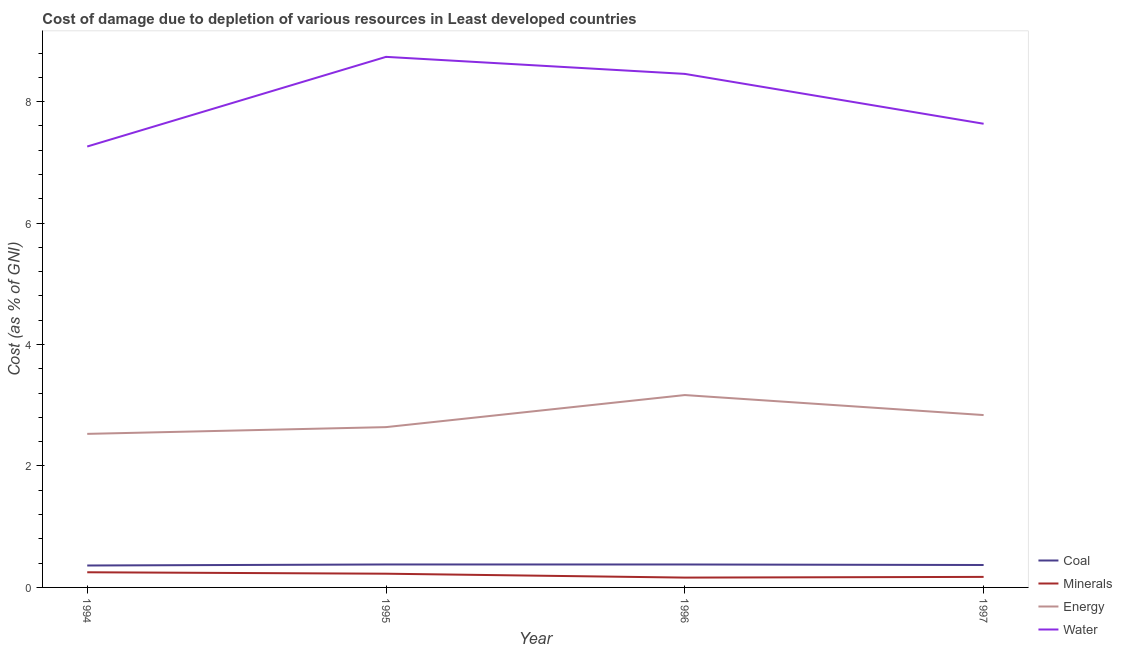Is the number of lines equal to the number of legend labels?
Your answer should be compact. Yes. What is the cost of damage due to depletion of minerals in 1994?
Make the answer very short. 0.25. Across all years, what is the maximum cost of damage due to depletion of minerals?
Give a very brief answer. 0.25. Across all years, what is the minimum cost of damage due to depletion of energy?
Your answer should be very brief. 2.53. What is the total cost of damage due to depletion of energy in the graph?
Ensure brevity in your answer.  11.17. What is the difference between the cost of damage due to depletion of water in 1995 and that in 1997?
Your response must be concise. 1.1. What is the difference between the cost of damage due to depletion of minerals in 1994 and the cost of damage due to depletion of coal in 1995?
Your answer should be very brief. -0.13. What is the average cost of damage due to depletion of energy per year?
Keep it short and to the point. 2.79. In the year 1995, what is the difference between the cost of damage due to depletion of energy and cost of damage due to depletion of minerals?
Provide a short and direct response. 2.41. What is the ratio of the cost of damage due to depletion of energy in 1994 to that in 1996?
Keep it short and to the point. 0.8. Is the difference between the cost of damage due to depletion of coal in 1994 and 1995 greater than the difference between the cost of damage due to depletion of energy in 1994 and 1995?
Offer a terse response. Yes. What is the difference between the highest and the second highest cost of damage due to depletion of coal?
Your answer should be compact. 0. What is the difference between the highest and the lowest cost of damage due to depletion of minerals?
Ensure brevity in your answer.  0.09. Is it the case that in every year, the sum of the cost of damage due to depletion of coal and cost of damage due to depletion of minerals is greater than the cost of damage due to depletion of energy?
Ensure brevity in your answer.  No. How many years are there in the graph?
Your answer should be very brief. 4. What is the difference between two consecutive major ticks on the Y-axis?
Provide a short and direct response. 2. Does the graph contain any zero values?
Keep it short and to the point. No. Does the graph contain grids?
Keep it short and to the point. No. How many legend labels are there?
Your answer should be compact. 4. How are the legend labels stacked?
Provide a short and direct response. Vertical. What is the title of the graph?
Keep it short and to the point. Cost of damage due to depletion of various resources in Least developed countries . Does "Source data assessment" appear as one of the legend labels in the graph?
Your answer should be very brief. No. What is the label or title of the X-axis?
Provide a short and direct response. Year. What is the label or title of the Y-axis?
Give a very brief answer. Cost (as % of GNI). What is the Cost (as % of GNI) of Coal in 1994?
Give a very brief answer. 0.36. What is the Cost (as % of GNI) of Minerals in 1994?
Keep it short and to the point. 0.25. What is the Cost (as % of GNI) in Energy in 1994?
Keep it short and to the point. 2.53. What is the Cost (as % of GNI) of Water in 1994?
Give a very brief answer. 7.26. What is the Cost (as % of GNI) of Coal in 1995?
Offer a very short reply. 0.38. What is the Cost (as % of GNI) in Minerals in 1995?
Ensure brevity in your answer.  0.23. What is the Cost (as % of GNI) of Energy in 1995?
Keep it short and to the point. 2.64. What is the Cost (as % of GNI) of Water in 1995?
Your response must be concise. 8.74. What is the Cost (as % of GNI) of Coal in 1996?
Your response must be concise. 0.38. What is the Cost (as % of GNI) of Minerals in 1996?
Your answer should be compact. 0.16. What is the Cost (as % of GNI) in Energy in 1996?
Provide a short and direct response. 3.17. What is the Cost (as % of GNI) in Water in 1996?
Your response must be concise. 8.46. What is the Cost (as % of GNI) of Coal in 1997?
Your answer should be compact. 0.37. What is the Cost (as % of GNI) of Minerals in 1997?
Your answer should be compact. 0.17. What is the Cost (as % of GNI) in Energy in 1997?
Offer a very short reply. 2.84. What is the Cost (as % of GNI) in Water in 1997?
Give a very brief answer. 7.64. Across all years, what is the maximum Cost (as % of GNI) in Coal?
Ensure brevity in your answer.  0.38. Across all years, what is the maximum Cost (as % of GNI) in Minerals?
Make the answer very short. 0.25. Across all years, what is the maximum Cost (as % of GNI) of Energy?
Provide a short and direct response. 3.17. Across all years, what is the maximum Cost (as % of GNI) in Water?
Make the answer very short. 8.74. Across all years, what is the minimum Cost (as % of GNI) in Coal?
Your answer should be very brief. 0.36. Across all years, what is the minimum Cost (as % of GNI) in Minerals?
Make the answer very short. 0.16. Across all years, what is the minimum Cost (as % of GNI) of Energy?
Your response must be concise. 2.53. Across all years, what is the minimum Cost (as % of GNI) in Water?
Give a very brief answer. 7.26. What is the total Cost (as % of GNI) of Coal in the graph?
Your response must be concise. 1.49. What is the total Cost (as % of GNI) in Minerals in the graph?
Make the answer very short. 0.81. What is the total Cost (as % of GNI) in Energy in the graph?
Your answer should be very brief. 11.17. What is the total Cost (as % of GNI) in Water in the graph?
Ensure brevity in your answer.  32.09. What is the difference between the Cost (as % of GNI) of Coal in 1994 and that in 1995?
Provide a short and direct response. -0.02. What is the difference between the Cost (as % of GNI) of Minerals in 1994 and that in 1995?
Ensure brevity in your answer.  0.02. What is the difference between the Cost (as % of GNI) of Energy in 1994 and that in 1995?
Ensure brevity in your answer.  -0.11. What is the difference between the Cost (as % of GNI) of Water in 1994 and that in 1995?
Ensure brevity in your answer.  -1.48. What is the difference between the Cost (as % of GNI) of Coal in 1994 and that in 1996?
Give a very brief answer. -0.02. What is the difference between the Cost (as % of GNI) in Minerals in 1994 and that in 1996?
Offer a terse response. 0.09. What is the difference between the Cost (as % of GNI) in Energy in 1994 and that in 1996?
Offer a terse response. -0.64. What is the difference between the Cost (as % of GNI) of Water in 1994 and that in 1996?
Your response must be concise. -1.2. What is the difference between the Cost (as % of GNI) in Coal in 1994 and that in 1997?
Your response must be concise. -0.01. What is the difference between the Cost (as % of GNI) in Minerals in 1994 and that in 1997?
Ensure brevity in your answer.  0.08. What is the difference between the Cost (as % of GNI) of Energy in 1994 and that in 1997?
Give a very brief answer. -0.31. What is the difference between the Cost (as % of GNI) of Water in 1994 and that in 1997?
Provide a short and direct response. -0.37. What is the difference between the Cost (as % of GNI) in Minerals in 1995 and that in 1996?
Your answer should be very brief. 0.06. What is the difference between the Cost (as % of GNI) in Energy in 1995 and that in 1996?
Offer a very short reply. -0.53. What is the difference between the Cost (as % of GNI) of Water in 1995 and that in 1996?
Keep it short and to the point. 0.28. What is the difference between the Cost (as % of GNI) in Coal in 1995 and that in 1997?
Offer a very short reply. 0.01. What is the difference between the Cost (as % of GNI) in Minerals in 1995 and that in 1997?
Provide a short and direct response. 0.05. What is the difference between the Cost (as % of GNI) in Energy in 1995 and that in 1997?
Provide a short and direct response. -0.2. What is the difference between the Cost (as % of GNI) in Water in 1995 and that in 1997?
Ensure brevity in your answer.  1.1. What is the difference between the Cost (as % of GNI) in Coal in 1996 and that in 1997?
Provide a succinct answer. 0.01. What is the difference between the Cost (as % of GNI) of Minerals in 1996 and that in 1997?
Offer a terse response. -0.01. What is the difference between the Cost (as % of GNI) in Energy in 1996 and that in 1997?
Your answer should be compact. 0.33. What is the difference between the Cost (as % of GNI) of Water in 1996 and that in 1997?
Ensure brevity in your answer.  0.82. What is the difference between the Cost (as % of GNI) in Coal in 1994 and the Cost (as % of GNI) in Minerals in 1995?
Your answer should be very brief. 0.13. What is the difference between the Cost (as % of GNI) of Coal in 1994 and the Cost (as % of GNI) of Energy in 1995?
Your answer should be very brief. -2.28. What is the difference between the Cost (as % of GNI) in Coal in 1994 and the Cost (as % of GNI) in Water in 1995?
Your answer should be very brief. -8.38. What is the difference between the Cost (as % of GNI) in Minerals in 1994 and the Cost (as % of GNI) in Energy in 1995?
Make the answer very short. -2.39. What is the difference between the Cost (as % of GNI) of Minerals in 1994 and the Cost (as % of GNI) of Water in 1995?
Your response must be concise. -8.49. What is the difference between the Cost (as % of GNI) in Energy in 1994 and the Cost (as % of GNI) in Water in 1995?
Offer a terse response. -6.21. What is the difference between the Cost (as % of GNI) in Coal in 1994 and the Cost (as % of GNI) in Minerals in 1996?
Offer a terse response. 0.2. What is the difference between the Cost (as % of GNI) of Coal in 1994 and the Cost (as % of GNI) of Energy in 1996?
Provide a short and direct response. -2.81. What is the difference between the Cost (as % of GNI) of Coal in 1994 and the Cost (as % of GNI) of Water in 1996?
Offer a terse response. -8.1. What is the difference between the Cost (as % of GNI) of Minerals in 1994 and the Cost (as % of GNI) of Energy in 1996?
Your answer should be very brief. -2.92. What is the difference between the Cost (as % of GNI) of Minerals in 1994 and the Cost (as % of GNI) of Water in 1996?
Keep it short and to the point. -8.21. What is the difference between the Cost (as % of GNI) in Energy in 1994 and the Cost (as % of GNI) in Water in 1996?
Make the answer very short. -5.93. What is the difference between the Cost (as % of GNI) in Coal in 1994 and the Cost (as % of GNI) in Minerals in 1997?
Your answer should be very brief. 0.19. What is the difference between the Cost (as % of GNI) of Coal in 1994 and the Cost (as % of GNI) of Energy in 1997?
Offer a terse response. -2.48. What is the difference between the Cost (as % of GNI) of Coal in 1994 and the Cost (as % of GNI) of Water in 1997?
Make the answer very short. -7.27. What is the difference between the Cost (as % of GNI) of Minerals in 1994 and the Cost (as % of GNI) of Energy in 1997?
Keep it short and to the point. -2.59. What is the difference between the Cost (as % of GNI) of Minerals in 1994 and the Cost (as % of GNI) of Water in 1997?
Offer a very short reply. -7.39. What is the difference between the Cost (as % of GNI) of Energy in 1994 and the Cost (as % of GNI) of Water in 1997?
Your response must be concise. -5.11. What is the difference between the Cost (as % of GNI) of Coal in 1995 and the Cost (as % of GNI) of Minerals in 1996?
Give a very brief answer. 0.22. What is the difference between the Cost (as % of GNI) in Coal in 1995 and the Cost (as % of GNI) in Energy in 1996?
Offer a terse response. -2.79. What is the difference between the Cost (as % of GNI) in Coal in 1995 and the Cost (as % of GNI) in Water in 1996?
Offer a very short reply. -8.08. What is the difference between the Cost (as % of GNI) of Minerals in 1995 and the Cost (as % of GNI) of Energy in 1996?
Your answer should be very brief. -2.94. What is the difference between the Cost (as % of GNI) of Minerals in 1995 and the Cost (as % of GNI) of Water in 1996?
Ensure brevity in your answer.  -8.23. What is the difference between the Cost (as % of GNI) of Energy in 1995 and the Cost (as % of GNI) of Water in 1996?
Offer a very short reply. -5.82. What is the difference between the Cost (as % of GNI) in Coal in 1995 and the Cost (as % of GNI) in Minerals in 1997?
Your answer should be compact. 0.2. What is the difference between the Cost (as % of GNI) of Coal in 1995 and the Cost (as % of GNI) of Energy in 1997?
Provide a short and direct response. -2.46. What is the difference between the Cost (as % of GNI) of Coal in 1995 and the Cost (as % of GNI) of Water in 1997?
Keep it short and to the point. -7.26. What is the difference between the Cost (as % of GNI) in Minerals in 1995 and the Cost (as % of GNI) in Energy in 1997?
Your response must be concise. -2.61. What is the difference between the Cost (as % of GNI) of Minerals in 1995 and the Cost (as % of GNI) of Water in 1997?
Make the answer very short. -7.41. What is the difference between the Cost (as % of GNI) of Energy in 1995 and the Cost (as % of GNI) of Water in 1997?
Keep it short and to the point. -5. What is the difference between the Cost (as % of GNI) of Coal in 1996 and the Cost (as % of GNI) of Minerals in 1997?
Keep it short and to the point. 0.2. What is the difference between the Cost (as % of GNI) in Coal in 1996 and the Cost (as % of GNI) in Energy in 1997?
Provide a succinct answer. -2.46. What is the difference between the Cost (as % of GNI) in Coal in 1996 and the Cost (as % of GNI) in Water in 1997?
Provide a short and direct response. -7.26. What is the difference between the Cost (as % of GNI) of Minerals in 1996 and the Cost (as % of GNI) of Energy in 1997?
Offer a very short reply. -2.68. What is the difference between the Cost (as % of GNI) of Minerals in 1996 and the Cost (as % of GNI) of Water in 1997?
Keep it short and to the point. -7.47. What is the difference between the Cost (as % of GNI) in Energy in 1996 and the Cost (as % of GNI) in Water in 1997?
Offer a terse response. -4.47. What is the average Cost (as % of GNI) in Coal per year?
Ensure brevity in your answer.  0.37. What is the average Cost (as % of GNI) of Minerals per year?
Give a very brief answer. 0.2. What is the average Cost (as % of GNI) of Energy per year?
Your answer should be compact. 2.79. What is the average Cost (as % of GNI) in Water per year?
Ensure brevity in your answer.  8.02. In the year 1994, what is the difference between the Cost (as % of GNI) of Coal and Cost (as % of GNI) of Minerals?
Ensure brevity in your answer.  0.11. In the year 1994, what is the difference between the Cost (as % of GNI) of Coal and Cost (as % of GNI) of Energy?
Offer a terse response. -2.17. In the year 1994, what is the difference between the Cost (as % of GNI) in Coal and Cost (as % of GNI) in Water?
Offer a very short reply. -6.9. In the year 1994, what is the difference between the Cost (as % of GNI) of Minerals and Cost (as % of GNI) of Energy?
Provide a succinct answer. -2.28. In the year 1994, what is the difference between the Cost (as % of GNI) of Minerals and Cost (as % of GNI) of Water?
Your answer should be compact. -7.01. In the year 1994, what is the difference between the Cost (as % of GNI) of Energy and Cost (as % of GNI) of Water?
Your answer should be very brief. -4.73. In the year 1995, what is the difference between the Cost (as % of GNI) of Coal and Cost (as % of GNI) of Minerals?
Offer a terse response. 0.15. In the year 1995, what is the difference between the Cost (as % of GNI) in Coal and Cost (as % of GNI) in Energy?
Offer a terse response. -2.26. In the year 1995, what is the difference between the Cost (as % of GNI) in Coal and Cost (as % of GNI) in Water?
Give a very brief answer. -8.36. In the year 1995, what is the difference between the Cost (as % of GNI) of Minerals and Cost (as % of GNI) of Energy?
Provide a succinct answer. -2.41. In the year 1995, what is the difference between the Cost (as % of GNI) of Minerals and Cost (as % of GNI) of Water?
Offer a terse response. -8.51. In the year 1995, what is the difference between the Cost (as % of GNI) in Energy and Cost (as % of GNI) in Water?
Give a very brief answer. -6.1. In the year 1996, what is the difference between the Cost (as % of GNI) of Coal and Cost (as % of GNI) of Minerals?
Offer a very short reply. 0.22. In the year 1996, what is the difference between the Cost (as % of GNI) in Coal and Cost (as % of GNI) in Energy?
Make the answer very short. -2.79. In the year 1996, what is the difference between the Cost (as % of GNI) in Coal and Cost (as % of GNI) in Water?
Ensure brevity in your answer.  -8.08. In the year 1996, what is the difference between the Cost (as % of GNI) of Minerals and Cost (as % of GNI) of Energy?
Your response must be concise. -3.01. In the year 1996, what is the difference between the Cost (as % of GNI) in Minerals and Cost (as % of GNI) in Water?
Your response must be concise. -8.29. In the year 1996, what is the difference between the Cost (as % of GNI) of Energy and Cost (as % of GNI) of Water?
Your answer should be compact. -5.29. In the year 1997, what is the difference between the Cost (as % of GNI) in Coal and Cost (as % of GNI) in Minerals?
Your response must be concise. 0.2. In the year 1997, what is the difference between the Cost (as % of GNI) of Coal and Cost (as % of GNI) of Energy?
Your answer should be very brief. -2.47. In the year 1997, what is the difference between the Cost (as % of GNI) in Coal and Cost (as % of GNI) in Water?
Give a very brief answer. -7.27. In the year 1997, what is the difference between the Cost (as % of GNI) in Minerals and Cost (as % of GNI) in Energy?
Offer a terse response. -2.66. In the year 1997, what is the difference between the Cost (as % of GNI) in Minerals and Cost (as % of GNI) in Water?
Offer a very short reply. -7.46. In the year 1997, what is the difference between the Cost (as % of GNI) of Energy and Cost (as % of GNI) of Water?
Offer a terse response. -4.8. What is the ratio of the Cost (as % of GNI) of Coal in 1994 to that in 1995?
Your answer should be very brief. 0.95. What is the ratio of the Cost (as % of GNI) of Minerals in 1994 to that in 1995?
Keep it short and to the point. 1.1. What is the ratio of the Cost (as % of GNI) of Energy in 1994 to that in 1995?
Provide a short and direct response. 0.96. What is the ratio of the Cost (as % of GNI) of Water in 1994 to that in 1995?
Give a very brief answer. 0.83. What is the ratio of the Cost (as % of GNI) in Coal in 1994 to that in 1996?
Give a very brief answer. 0.96. What is the ratio of the Cost (as % of GNI) of Minerals in 1994 to that in 1996?
Your answer should be very brief. 1.54. What is the ratio of the Cost (as % of GNI) of Energy in 1994 to that in 1996?
Your answer should be very brief. 0.8. What is the ratio of the Cost (as % of GNI) of Water in 1994 to that in 1996?
Keep it short and to the point. 0.86. What is the ratio of the Cost (as % of GNI) in Coal in 1994 to that in 1997?
Make the answer very short. 0.98. What is the ratio of the Cost (as % of GNI) of Minerals in 1994 to that in 1997?
Ensure brevity in your answer.  1.44. What is the ratio of the Cost (as % of GNI) of Energy in 1994 to that in 1997?
Ensure brevity in your answer.  0.89. What is the ratio of the Cost (as % of GNI) in Water in 1994 to that in 1997?
Keep it short and to the point. 0.95. What is the ratio of the Cost (as % of GNI) in Coal in 1995 to that in 1996?
Offer a very short reply. 1. What is the ratio of the Cost (as % of GNI) of Minerals in 1995 to that in 1996?
Provide a succinct answer. 1.4. What is the ratio of the Cost (as % of GNI) of Energy in 1995 to that in 1996?
Keep it short and to the point. 0.83. What is the ratio of the Cost (as % of GNI) of Water in 1995 to that in 1996?
Your answer should be compact. 1.03. What is the ratio of the Cost (as % of GNI) of Coal in 1995 to that in 1997?
Your answer should be very brief. 1.02. What is the ratio of the Cost (as % of GNI) of Minerals in 1995 to that in 1997?
Your answer should be very brief. 1.3. What is the ratio of the Cost (as % of GNI) of Energy in 1995 to that in 1997?
Your response must be concise. 0.93. What is the ratio of the Cost (as % of GNI) of Water in 1995 to that in 1997?
Keep it short and to the point. 1.14. What is the ratio of the Cost (as % of GNI) in Coal in 1996 to that in 1997?
Make the answer very short. 1.02. What is the ratio of the Cost (as % of GNI) of Minerals in 1996 to that in 1997?
Your answer should be very brief. 0.93. What is the ratio of the Cost (as % of GNI) in Energy in 1996 to that in 1997?
Ensure brevity in your answer.  1.12. What is the ratio of the Cost (as % of GNI) of Water in 1996 to that in 1997?
Give a very brief answer. 1.11. What is the difference between the highest and the second highest Cost (as % of GNI) of Minerals?
Provide a succinct answer. 0.02. What is the difference between the highest and the second highest Cost (as % of GNI) of Energy?
Offer a very short reply. 0.33. What is the difference between the highest and the second highest Cost (as % of GNI) in Water?
Your response must be concise. 0.28. What is the difference between the highest and the lowest Cost (as % of GNI) of Coal?
Give a very brief answer. 0.02. What is the difference between the highest and the lowest Cost (as % of GNI) of Minerals?
Keep it short and to the point. 0.09. What is the difference between the highest and the lowest Cost (as % of GNI) of Energy?
Provide a short and direct response. 0.64. What is the difference between the highest and the lowest Cost (as % of GNI) in Water?
Make the answer very short. 1.48. 